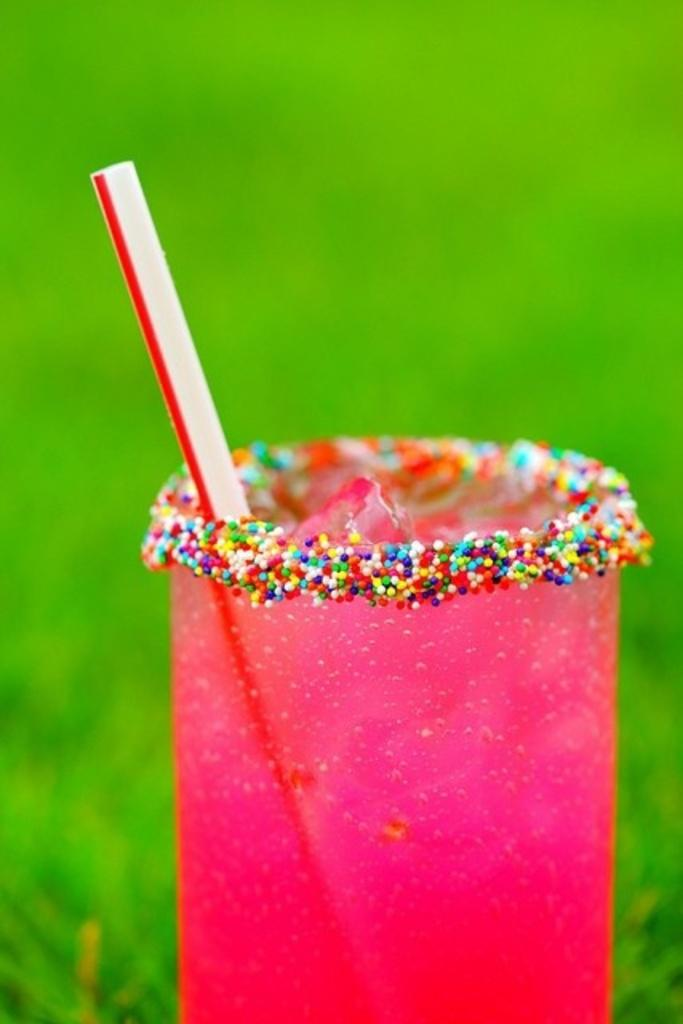What object is present in the image that can hold a liquid? There is a glass in the image. What color is the glass? The glass is pink in color. Is there anything inside the glass? Yes, there is a straw in the glass. What can be seen in the background of the image? The background of the image is green. What type of soda is being served in the glass? There is no soda present in the image; it only shows a pink glass with a straw. 